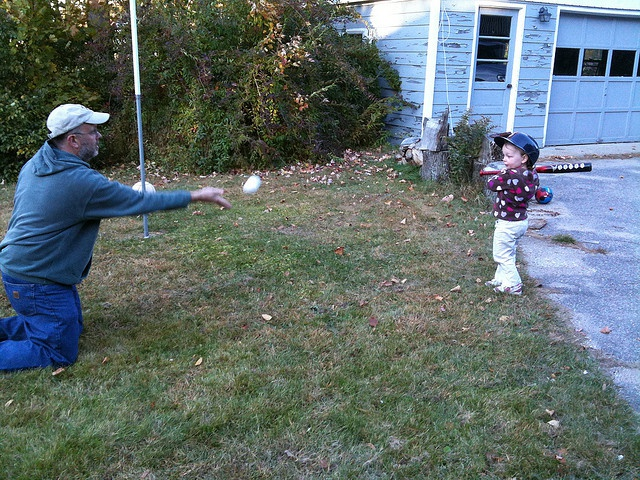Describe the objects in this image and their specific colors. I can see people in darkgreen, navy, blue, black, and darkblue tones, people in darkgreen, white, black, gray, and purple tones, baseball bat in darkgreen, black, white, blue, and purple tones, sports ball in darkgreen, white, lightblue, and darkgray tones, and sports ball in darkgreen, white, gray, and darkgray tones in this image. 